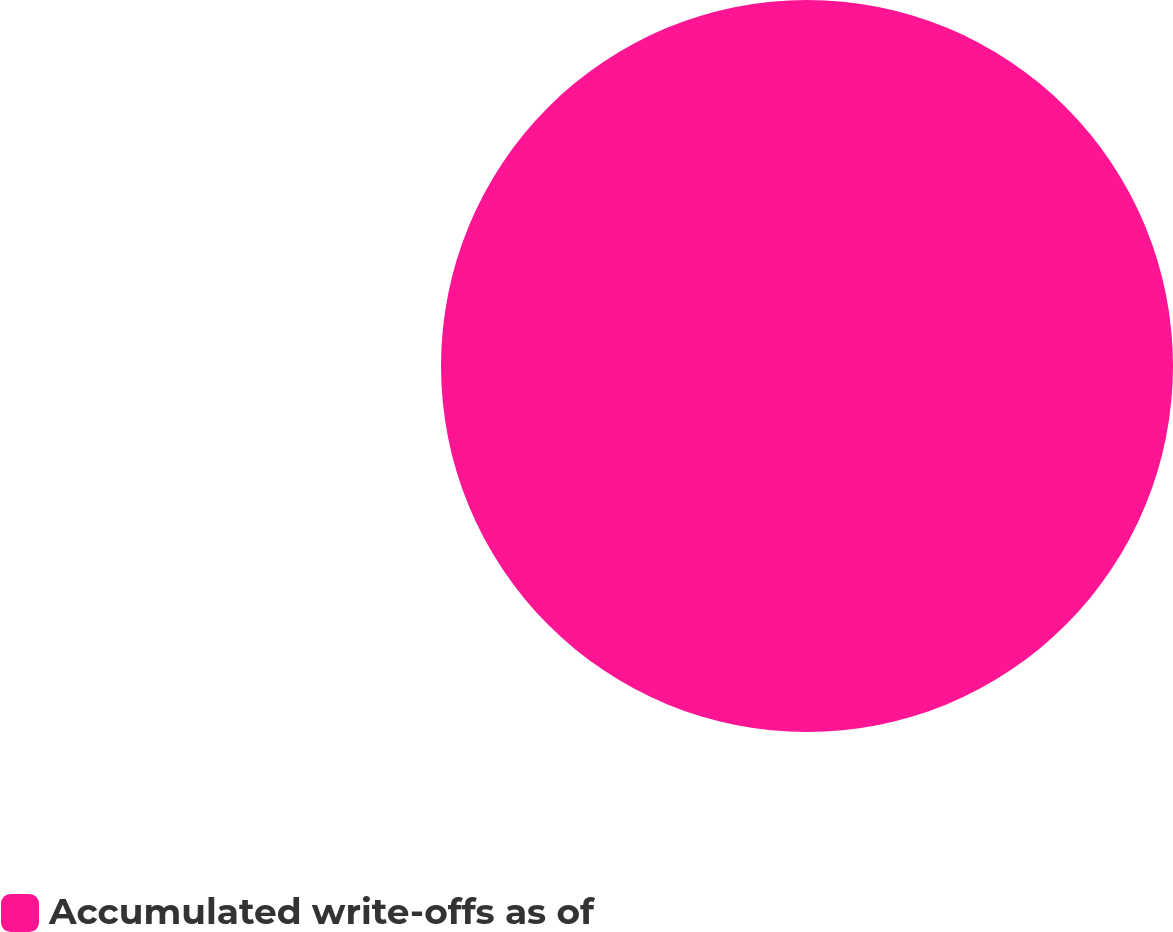<chart> <loc_0><loc_0><loc_500><loc_500><pie_chart><fcel>Accumulated write-offs as of<nl><fcel>100.0%<nl></chart> 